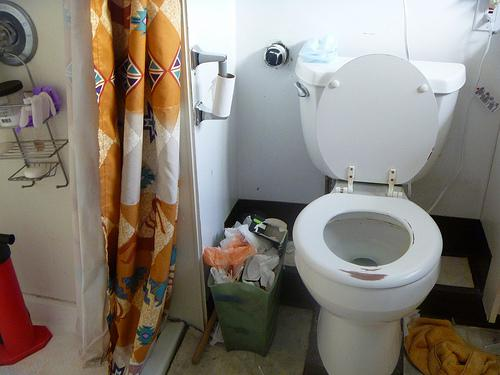Question: when is this taken?
Choices:
A. Nighttime.
B. Evening.
C. Dawn.
D. Daytime.
Answer with the letter. Answer: D Question: what color is the trash can?
Choices:
A. Teal.
B. Green.
C. Purple.
D. Neon.
Answer with the letter. Answer: B Question: where is the yellow towel?
Choices:
A. On the towel rack.
B. On the floor.
C. On the hook.
D. Over the shower door.
Answer with the letter. Answer: B 